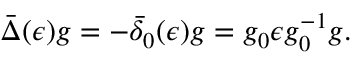Convert formula to latex. <formula><loc_0><loc_0><loc_500><loc_500>\bar { \Delta } ( \epsilon ) g = - \bar { \delta } _ { 0 } ( \epsilon ) g = g _ { 0 } \epsilon g _ { 0 } ^ { - 1 } g .</formula> 